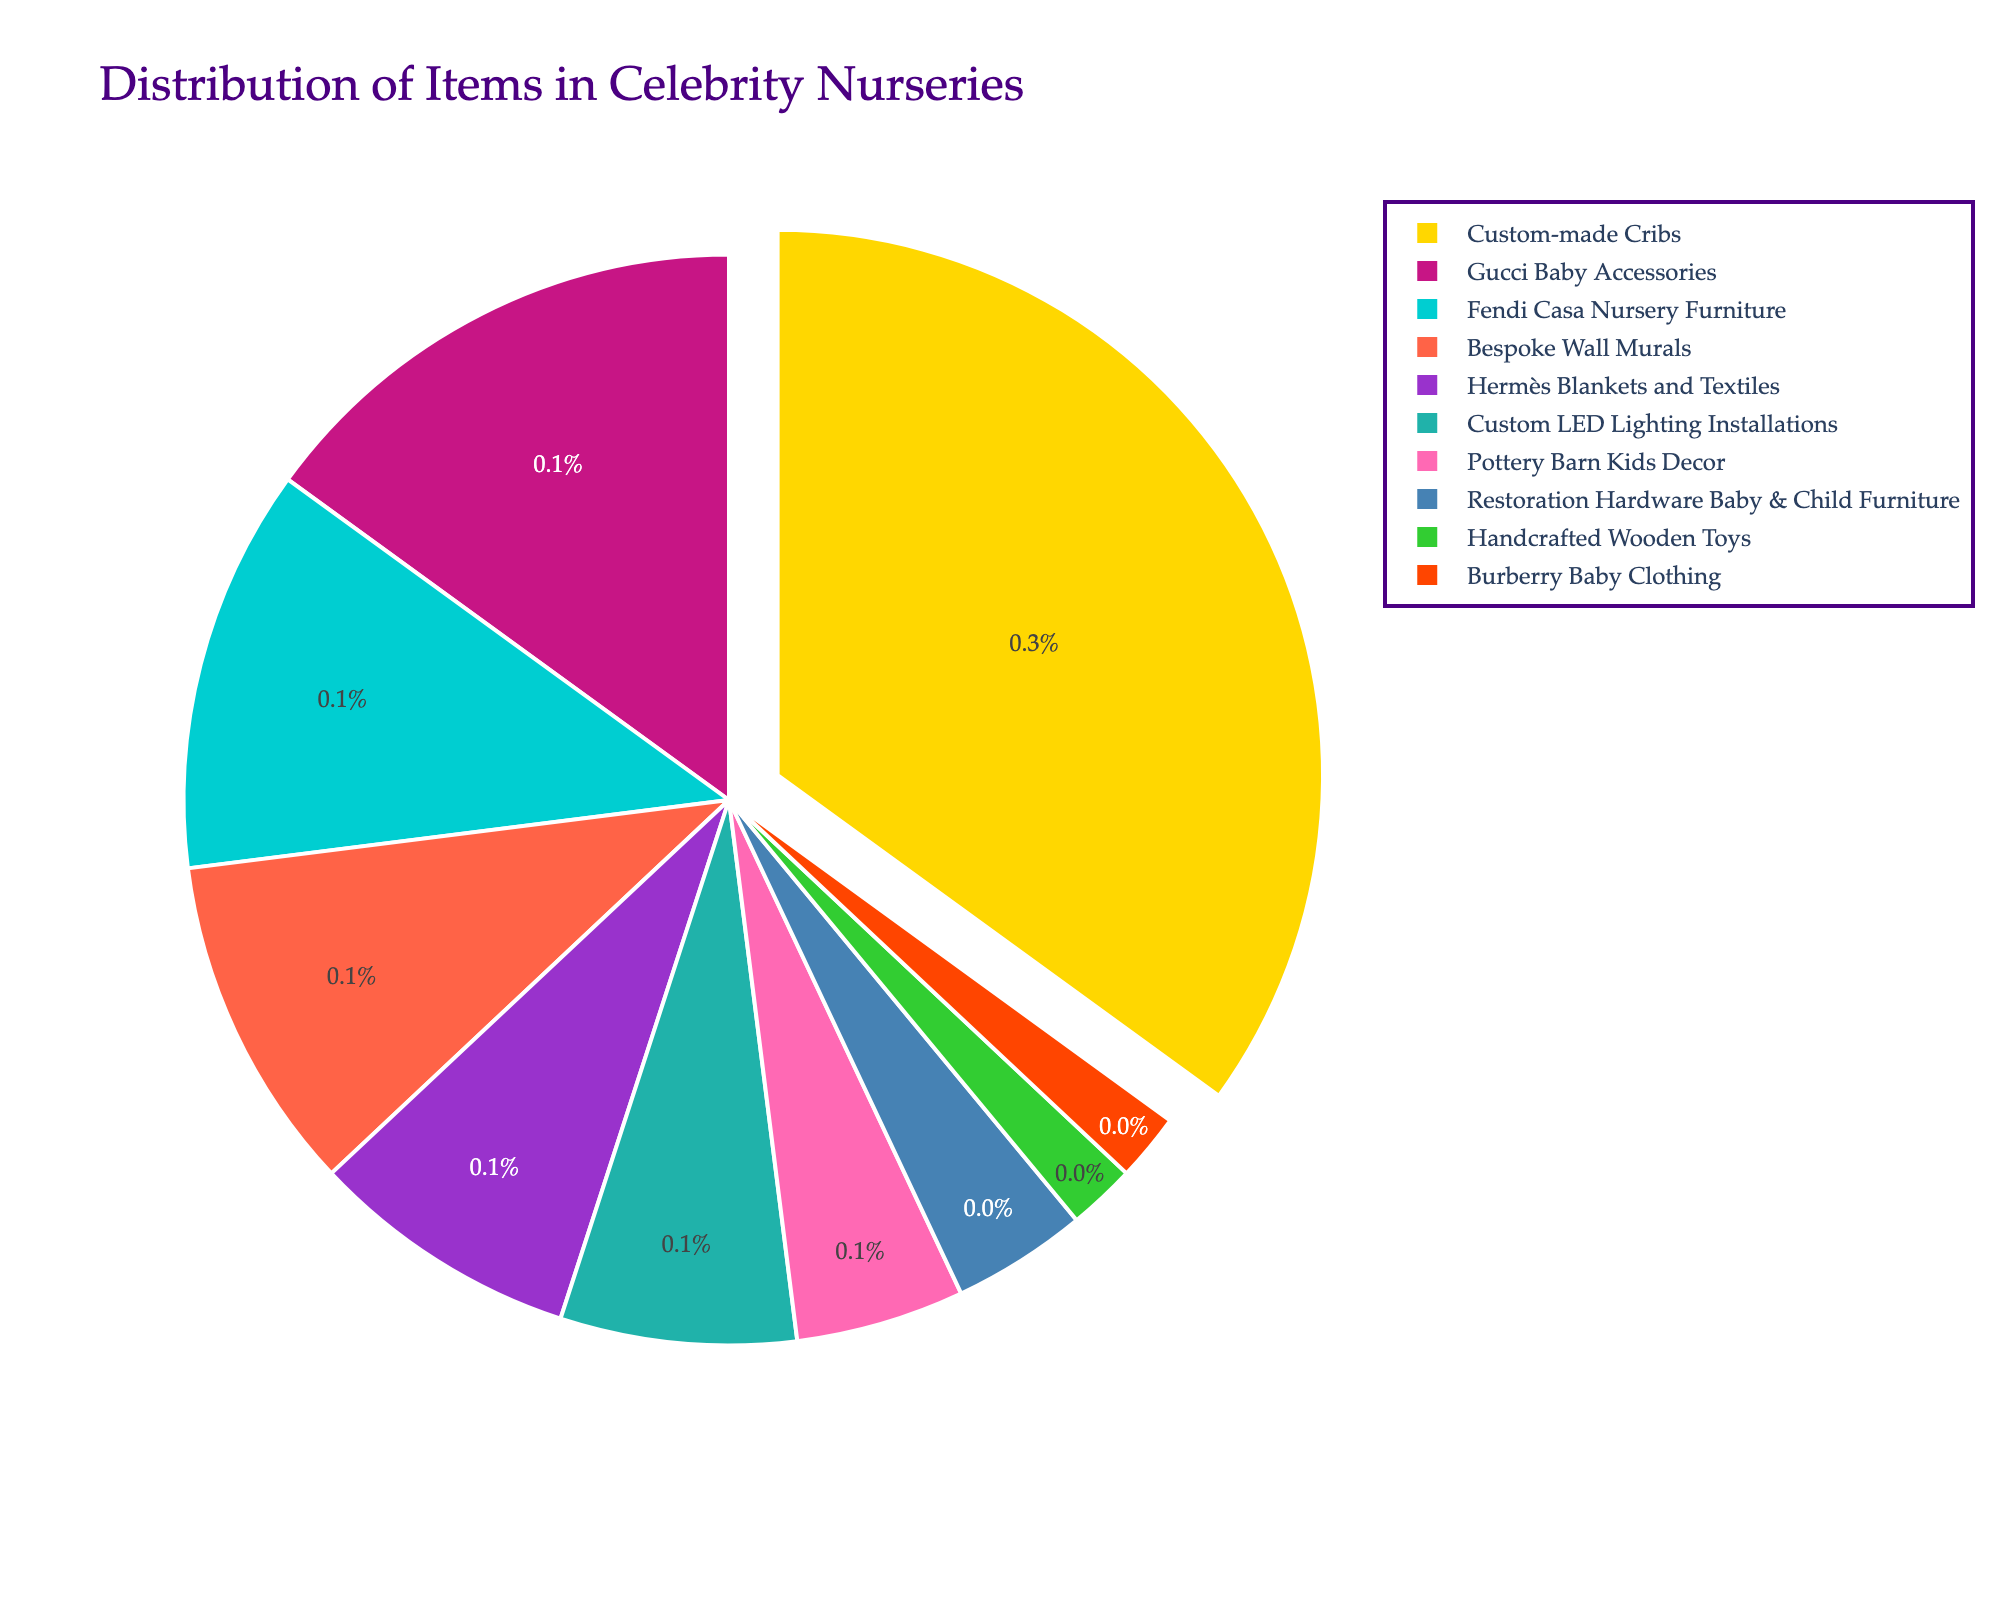How many types of items contribute to the distribution? The pie chart displays various items classified into segments representing different percentages. To determine the number of types, count each distinct segment in the chart.
Answer: 10 Which item type has the highest proportion, and what percentage does it hold? Identify the segment with the largest area in the pie chart. The label inside this largest slice specifies the item type and its percentage.
Answer: Custom-made Cribs, 35% What is the combined percentage of Gucci Baby Accessories and Fendi Casa Nursery Furniture? Locate the two segments labeled "Gucci Baby Accessories" and "Fendi Casa Nursery Furniture." Sum their respective percentages: 15% for Gucci Baby Accessories and 12% for Fendi Casa Nursery Furniture. Add these values together.
Answer: 27% Which item type has the smallest contribution and what percentage is it? Locate the smallest slice in the pie chart. The label inside or beside this slice will identify the item type and its percentage.
Answer: Handcrafted Wooden Toys and Burberry Baby Clothing, 2% Is the percentage of Bespoke Wall Murals greater than that of Hermès Blankets and Textiles? Compare the two slices labeled "Bespoke Wall Murals" and "Hermès Blankets and Textiles." Check the percentages given for each: Bespoke Wall Murals is 10%, Hermès Blankets and Textiles is 8%.
Answer: Yes Are there more custom-made items or designer brand items in the nursery distribution? Consider Custom-made Cribs, Bespoke Wall Murals, Custom LED Lighting Installations, Handcrafted Wooden Toys versus the rest. Sum the percentages of Custom-made Cribs (35%), Bespoke Wall Murals (10%), Custom LED Lighting Installations (7%), and Handcrafted Wooden Toys (2%). Compare this total with the sum of percentages of all designer brand items given. Custom-made items: \( 35% + 10% + 7% + 2% = 54% \). Designer brand items: \( 15% + 12% + 8% + 5% + 4% + 2% = 46% \).
Answer: Custom-made items What is the percentage difference between the Custom-made Cribs and Pottery Barn Kids Decor? Identify the percentages for Custom-made Cribs (35%) and Pottery Barn Kids Decor (5%). Subtract the smaller percentage from the larger one: \( 35% - 5% \).
Answer: 30% Which two items together contribute to more than half of the distribution? Evaluate the segments to find pairs of item types whose combined percentages exceed 50%. "Custom-made Cribs" is the largest at 35%, and adding "Gucci Baby Accessories" (15%) or "Fendi Casa Nursery Furniture" (12%) to it will exceed 50%. Custom-made Cribs and Gucci Baby Accessories: \( 35% + 15% \).
Answer: Custom-made Cribs and Gucci Baby Accessories Compare the contributions of Restoration Hardware Baby & Child Furniture and Hermès Blankets and Textiles. Which is greater and by how much? Identify Restoration Hardware Baby & Child Furniture (4%) and Hermès Blankets and Textiles (8%). Subtract the smaller percentage from the larger one: \( 8% - 4% \).
Answer: Hermès Blankets and Textiles, 4% What is the ranking of Custom LED Lighting Installations in terms of percentage contribution? List the percentages of all items in descending order: 35%, 15%, 12%, 10%, 8%, 7%, 5%, 4%, 2%, 2%. Identify the position of Custom LED Lighting Installations (7%) in this ordered list.
Answer: 6th 